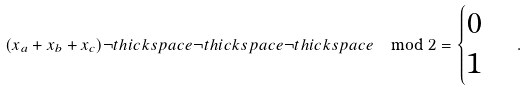<formula> <loc_0><loc_0><loc_500><loc_500>( x _ { a } + x _ { b } + x _ { c } ) \neg t h i c k s p a c e \neg t h i c k s p a c e \neg t h i c k s p a c e \mod 2 = \begin{cases} 0 \\ 1 \end{cases} .</formula> 